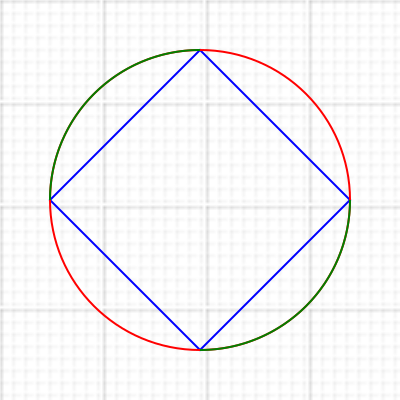In this geometric pattern inspired by Islamic architecture, a square is inscribed within a circle. If the side length of the square is 300 units, what is the area of the region bounded by one quarter of the circle and two sides of the square? Let's approach this step-by-step:

1) First, we need to find the radius of the circle. Since the square is inscribed in the circle, its diagonal forms the diameter of the circle.

2) The diagonal of a square can be calculated using the Pythagorean theorem:
   $d^2 = s^2 + s^2 = 2s^2$
   Where $d$ is the diagonal and $s$ is the side length.

3) Given the side length $s = 300$, we can calculate the diagonal:
   $d^2 = 2(300^2) = 180000$
   $d = \sqrt{180000} = 300\sqrt{2}$

4) The radius $r$ is half of this: $r = \frac{300\sqrt{2}}{2} = 150\sqrt{2}$

5) The area of the quarter circle is:
   $A_{quarter} = \frac{1}{4} \pi r^2 = \frac{1}{4} \pi (150\sqrt{2})^2 = \frac{45000\pi}{2}$

6) The area of the triangle formed by two sides of the square and the radius is:
   $A_{triangle} = \frac{1}{2} * 300 * 300 = 45000$

7) The area we're looking for is the difference between these:
   $A = A_{quarter} - A_{triangle} = \frac{45000\pi}{2} - 45000$

8) Simplifying: $A = 45000(\frac{\pi}{2} - 1)$
Answer: $45000(\frac{\pi}{2} - 1)$ square units 